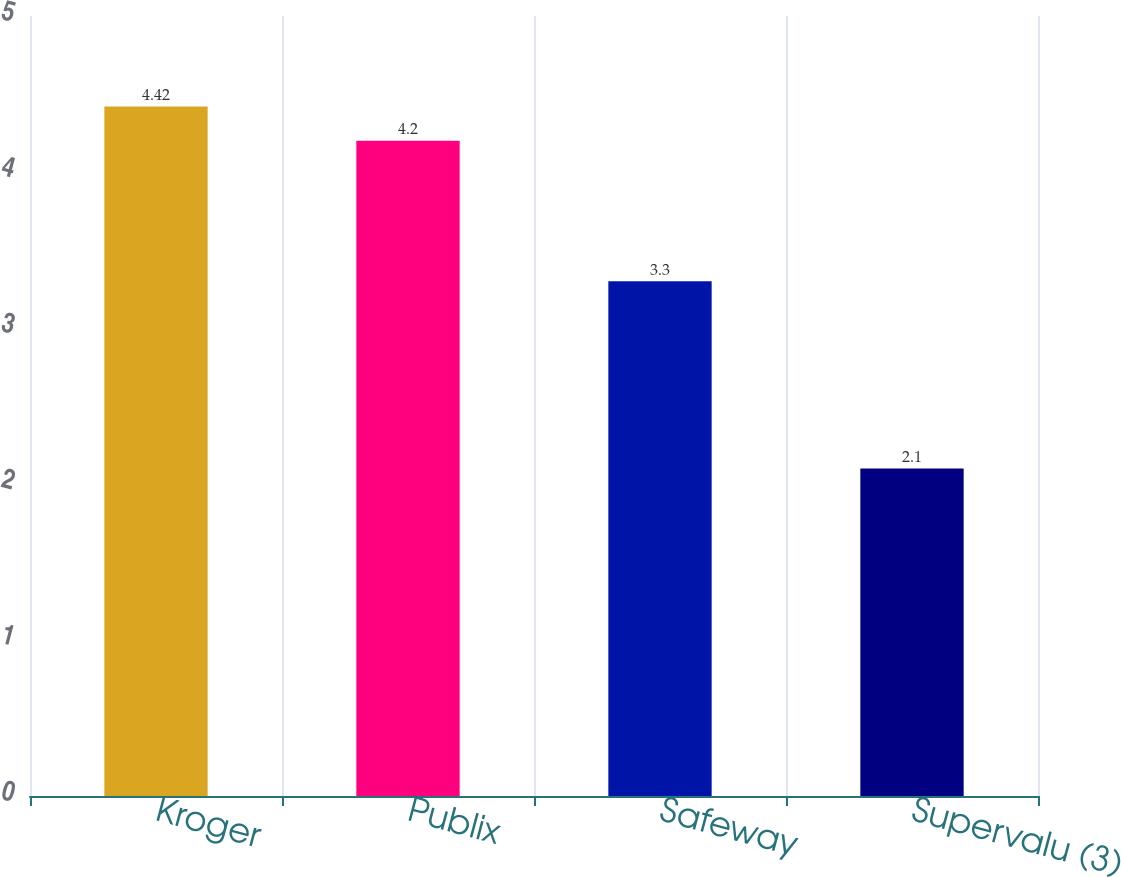Convert chart. <chart><loc_0><loc_0><loc_500><loc_500><bar_chart><fcel>Kroger<fcel>Publix<fcel>Safeway<fcel>Supervalu (3)<nl><fcel>4.42<fcel>4.2<fcel>3.3<fcel>2.1<nl></chart> 